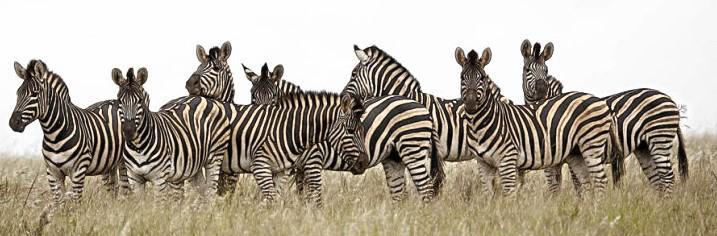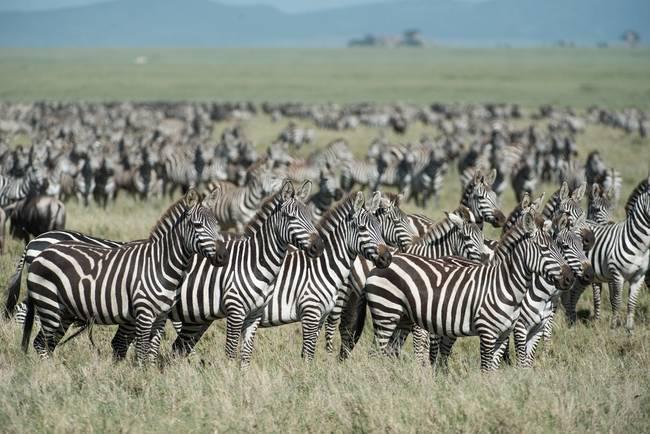The first image is the image on the left, the second image is the image on the right. Given the left and right images, does the statement "There are clouds visible in the left image." hold true? Answer yes or no. No. The first image is the image on the left, the second image is the image on the right. For the images displayed, is the sentence "The right image shows dark hooved animals grazing behind zebra, and the left image shows zebra in a field with no watering hole visible." factually correct? Answer yes or no. No. 